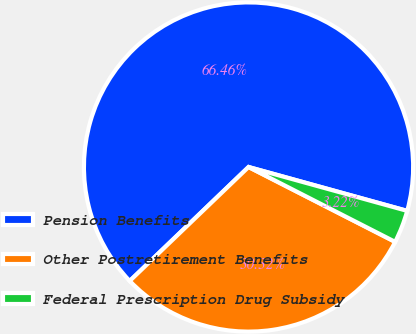Convert chart. <chart><loc_0><loc_0><loc_500><loc_500><pie_chart><fcel>Pension Benefits<fcel>Other Postretirement Benefits<fcel>Federal Prescription Drug Subsidy<nl><fcel>66.46%<fcel>30.32%<fcel>3.22%<nl></chart> 